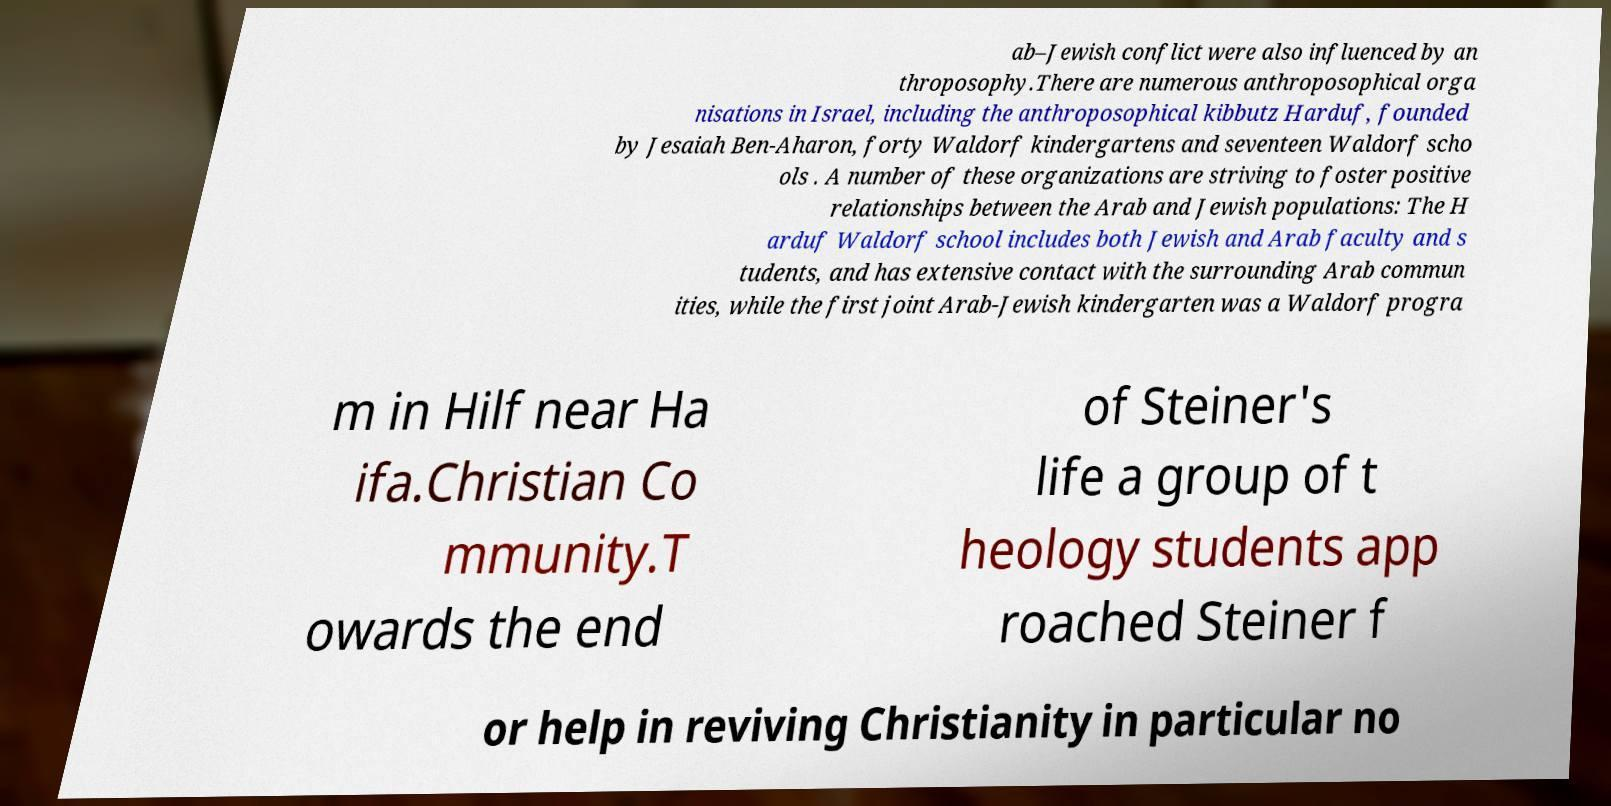What messages or text are displayed in this image? I need them in a readable, typed format. ab–Jewish conflict were also influenced by an throposophy.There are numerous anthroposophical orga nisations in Israel, including the anthroposophical kibbutz Harduf, founded by Jesaiah Ben-Aharon, forty Waldorf kindergartens and seventeen Waldorf scho ols . A number of these organizations are striving to foster positive relationships between the Arab and Jewish populations: The H arduf Waldorf school includes both Jewish and Arab faculty and s tudents, and has extensive contact with the surrounding Arab commun ities, while the first joint Arab-Jewish kindergarten was a Waldorf progra m in Hilf near Ha ifa.Christian Co mmunity.T owards the end of Steiner's life a group of t heology students app roached Steiner f or help in reviving Christianity in particular no 